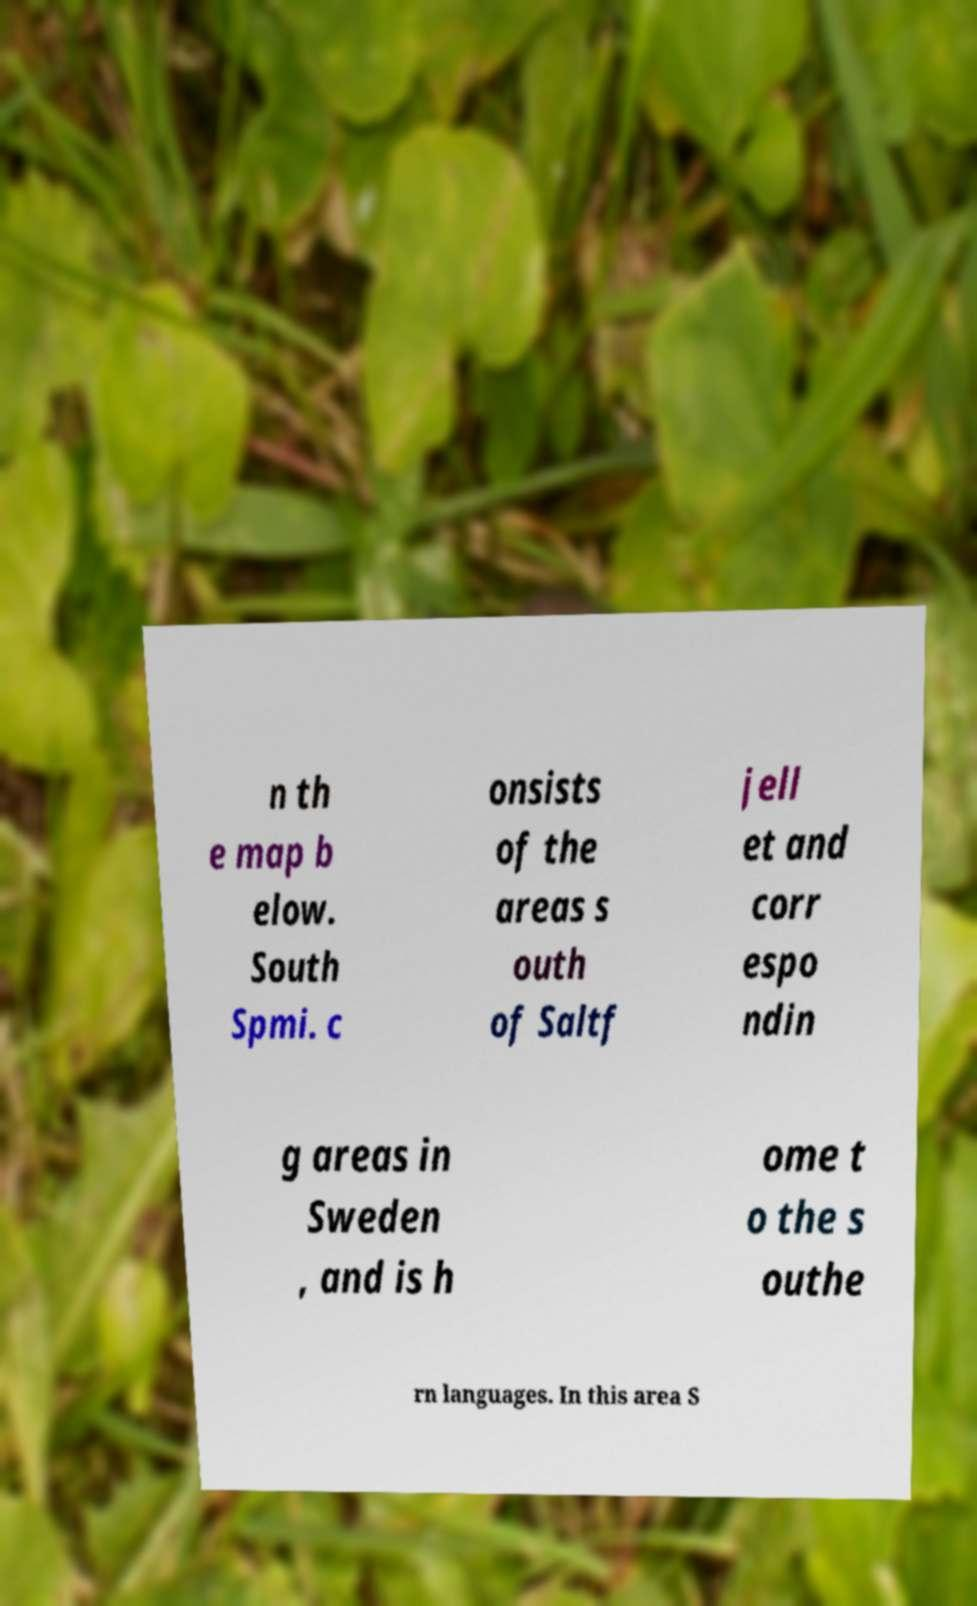For documentation purposes, I need the text within this image transcribed. Could you provide that? n th e map b elow. South Spmi. c onsists of the areas s outh of Saltf jell et and corr espo ndin g areas in Sweden , and is h ome t o the s outhe rn languages. In this area S 